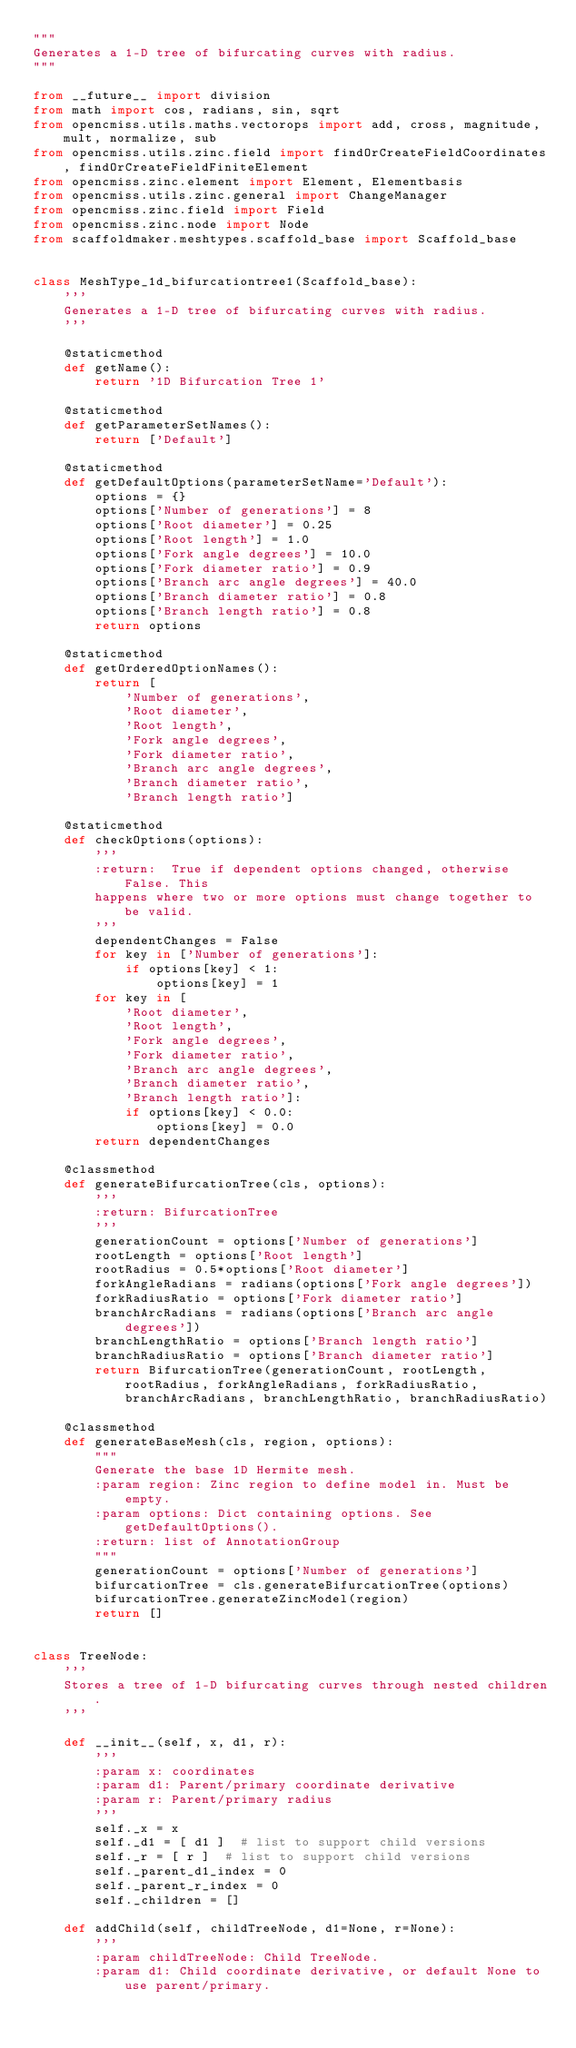<code> <loc_0><loc_0><loc_500><loc_500><_Python_>"""
Generates a 1-D tree of bifurcating curves with radius.
"""

from __future__ import division
from math import cos, radians, sin, sqrt
from opencmiss.utils.maths.vectorops import add, cross, magnitude, mult, normalize, sub
from opencmiss.utils.zinc.field import findOrCreateFieldCoordinates, findOrCreateFieldFiniteElement
from opencmiss.zinc.element import Element, Elementbasis
from opencmiss.utils.zinc.general import ChangeManager
from opencmiss.zinc.field import Field
from opencmiss.zinc.node import Node
from scaffoldmaker.meshtypes.scaffold_base import Scaffold_base


class MeshType_1d_bifurcationtree1(Scaffold_base):
    '''
    Generates a 1-D tree of bifurcating curves with radius.
    '''

    @staticmethod
    def getName():
        return '1D Bifurcation Tree 1'

    @staticmethod
    def getParameterSetNames():
        return ['Default']

    @staticmethod
    def getDefaultOptions(parameterSetName='Default'):
        options = {}
        options['Number of generations'] = 8
        options['Root diameter'] = 0.25
        options['Root length'] = 1.0
        options['Fork angle degrees'] = 10.0
        options['Fork diameter ratio'] = 0.9
        options['Branch arc angle degrees'] = 40.0
        options['Branch diameter ratio'] = 0.8
        options['Branch length ratio'] = 0.8
        return options

    @staticmethod
    def getOrderedOptionNames():
        return [
            'Number of generations',
            'Root diameter',
            'Root length',
            'Fork angle degrees',
            'Fork diameter ratio',
            'Branch arc angle degrees',
            'Branch diameter ratio',
            'Branch length ratio']

    @staticmethod
    def checkOptions(options):
        '''
        :return:  True if dependent options changed, otherwise False. This
        happens where two or more options must change together to be valid.
        '''
        dependentChanges = False
        for key in ['Number of generations']:
            if options[key] < 1:
                options[key] = 1
        for key in [
            'Root diameter',
            'Root length',
            'Fork angle degrees',
            'Fork diameter ratio',
            'Branch arc angle degrees',
            'Branch diameter ratio',
            'Branch length ratio']:
            if options[key] < 0.0:
                options[key] = 0.0
        return dependentChanges

    @classmethod
    def generateBifurcationTree(cls, options):
        '''
        :return: BifurcationTree
        '''
        generationCount = options['Number of generations']
        rootLength = options['Root length']
        rootRadius = 0.5*options['Root diameter']
        forkAngleRadians = radians(options['Fork angle degrees'])
        forkRadiusRatio = options['Fork diameter ratio']
        branchArcRadians = radians(options['Branch arc angle degrees'])
        branchLengthRatio = options['Branch length ratio']
        branchRadiusRatio = options['Branch diameter ratio']
        return BifurcationTree(generationCount, rootLength, rootRadius, forkAngleRadians, forkRadiusRatio, branchArcRadians, branchLengthRatio, branchRadiusRatio)

    @classmethod
    def generateBaseMesh(cls, region, options):
        """
        Generate the base 1D Hermite mesh.
        :param region: Zinc region to define model in. Must be empty.
        :param options: Dict containing options. See getDefaultOptions().
        :return: list of AnnotationGroup
        """
        generationCount = options['Number of generations']
        bifurcationTree = cls.generateBifurcationTree(options)
        bifurcationTree.generateZincModel(region)
        return []


class TreeNode:
    '''
    Stores a tree of 1-D bifurcating curves through nested children.
    '''

    def __init__(self, x, d1, r):
        '''
        :param x: coordinates
        :param d1: Parent/primary coordinate derivative
        :param r: Parent/primary radius
        '''
        self._x = x
        self._d1 = [ d1 ]  # list to support child versions
        self._r = [ r ]  # list to support child versions
        self._parent_d1_index = 0
        self._parent_r_index = 0
        self._children = []

    def addChild(self, childTreeNode, d1=None, r=None):
        '''
        :param childTreeNode: Child TreeNode.
        :param d1: Child coordinate derivative, or default None to use parent/primary.</code> 